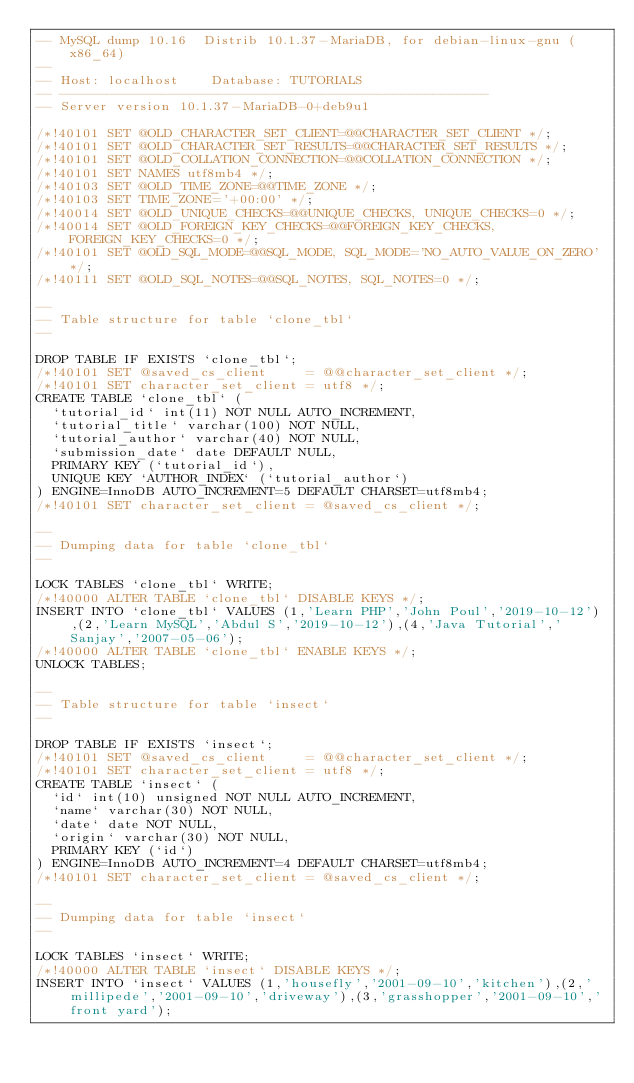<code> <loc_0><loc_0><loc_500><loc_500><_SQL_>-- MySQL dump 10.16  Distrib 10.1.37-MariaDB, for debian-linux-gnu (x86_64)
--
-- Host: localhost    Database: TUTORIALS
-- ------------------------------------------------------
-- Server version	10.1.37-MariaDB-0+deb9u1

/*!40101 SET @OLD_CHARACTER_SET_CLIENT=@@CHARACTER_SET_CLIENT */;
/*!40101 SET @OLD_CHARACTER_SET_RESULTS=@@CHARACTER_SET_RESULTS */;
/*!40101 SET @OLD_COLLATION_CONNECTION=@@COLLATION_CONNECTION */;
/*!40101 SET NAMES utf8mb4 */;
/*!40103 SET @OLD_TIME_ZONE=@@TIME_ZONE */;
/*!40103 SET TIME_ZONE='+00:00' */;
/*!40014 SET @OLD_UNIQUE_CHECKS=@@UNIQUE_CHECKS, UNIQUE_CHECKS=0 */;
/*!40014 SET @OLD_FOREIGN_KEY_CHECKS=@@FOREIGN_KEY_CHECKS, FOREIGN_KEY_CHECKS=0 */;
/*!40101 SET @OLD_SQL_MODE=@@SQL_MODE, SQL_MODE='NO_AUTO_VALUE_ON_ZERO' */;
/*!40111 SET @OLD_SQL_NOTES=@@SQL_NOTES, SQL_NOTES=0 */;

--
-- Table structure for table `clone_tbl`
--

DROP TABLE IF EXISTS `clone_tbl`;
/*!40101 SET @saved_cs_client     = @@character_set_client */;
/*!40101 SET character_set_client = utf8 */;
CREATE TABLE `clone_tbl` (
  `tutorial_id` int(11) NOT NULL AUTO_INCREMENT,
  `tutorial_title` varchar(100) NOT NULL,
  `tutorial_author` varchar(40) NOT NULL,
  `submission_date` date DEFAULT NULL,
  PRIMARY KEY (`tutorial_id`),
  UNIQUE KEY `AUTHOR_INDEX` (`tutorial_author`)
) ENGINE=InnoDB AUTO_INCREMENT=5 DEFAULT CHARSET=utf8mb4;
/*!40101 SET character_set_client = @saved_cs_client */;

--
-- Dumping data for table `clone_tbl`
--

LOCK TABLES `clone_tbl` WRITE;
/*!40000 ALTER TABLE `clone_tbl` DISABLE KEYS */;
INSERT INTO `clone_tbl` VALUES (1,'Learn PHP','John Poul','2019-10-12'),(2,'Learn MySQL','Abdul S','2019-10-12'),(4,'Java Tutorial','Sanjay','2007-05-06');
/*!40000 ALTER TABLE `clone_tbl` ENABLE KEYS */;
UNLOCK TABLES;

--
-- Table structure for table `insect`
--

DROP TABLE IF EXISTS `insect`;
/*!40101 SET @saved_cs_client     = @@character_set_client */;
/*!40101 SET character_set_client = utf8 */;
CREATE TABLE `insect` (
  `id` int(10) unsigned NOT NULL AUTO_INCREMENT,
  `name` varchar(30) NOT NULL,
  `date` date NOT NULL,
  `origin` varchar(30) NOT NULL,
  PRIMARY KEY (`id`)
) ENGINE=InnoDB AUTO_INCREMENT=4 DEFAULT CHARSET=utf8mb4;
/*!40101 SET character_set_client = @saved_cs_client */;

--
-- Dumping data for table `insect`
--

LOCK TABLES `insect` WRITE;
/*!40000 ALTER TABLE `insect` DISABLE KEYS */;
INSERT INTO `insect` VALUES (1,'housefly','2001-09-10','kitchen'),(2,'millipede','2001-09-10','driveway'),(3,'grasshopper','2001-09-10','front yard');</code> 